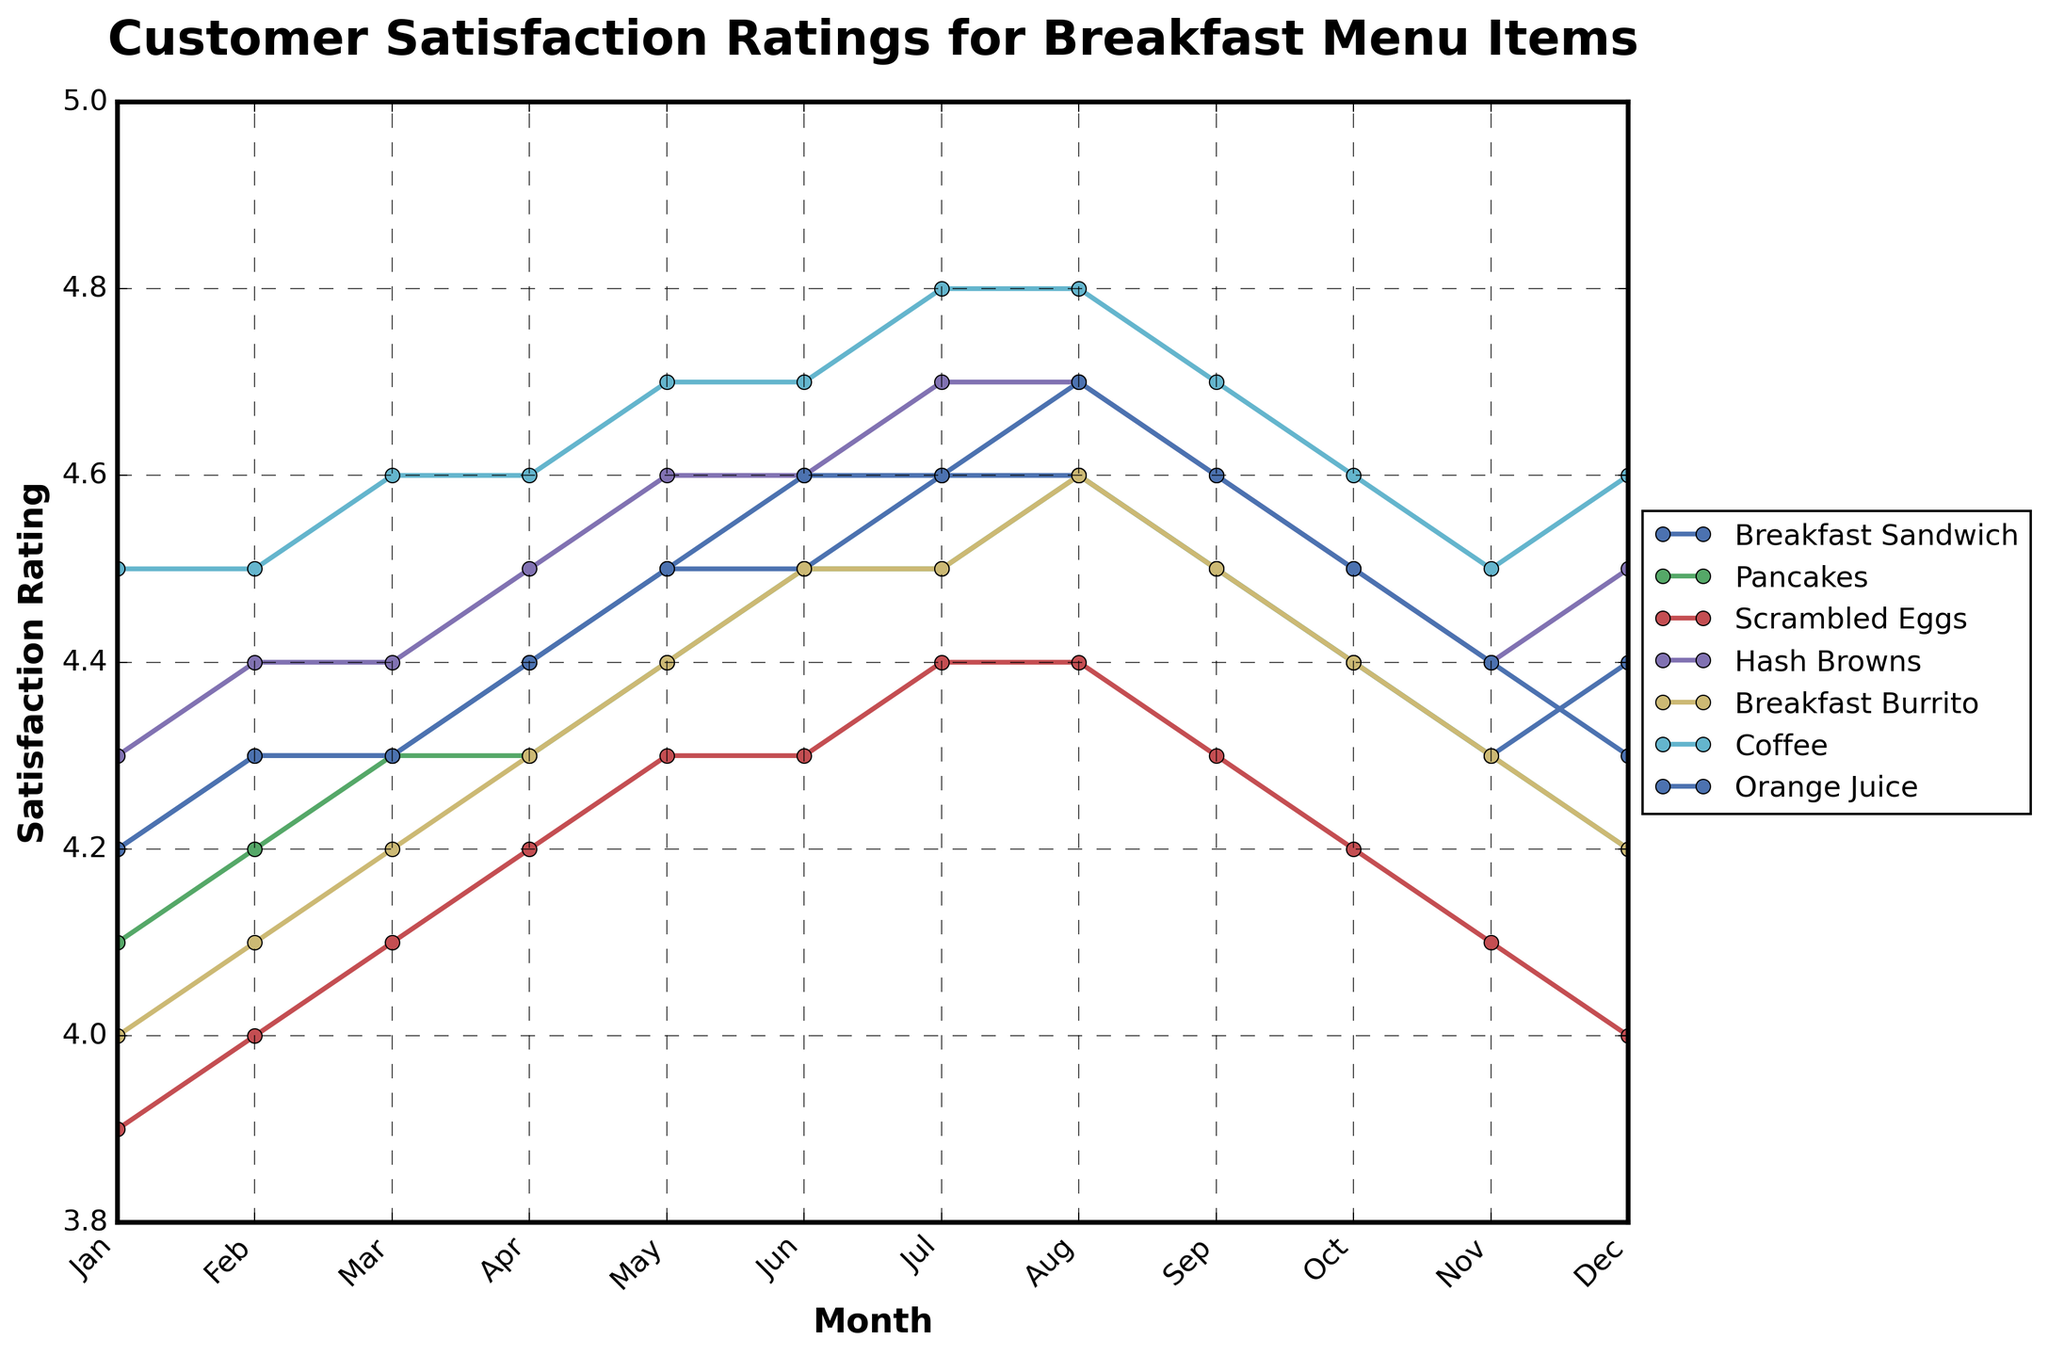What's the trend in customer satisfaction ratings for the Coffee over the year? The Coffee's customer satisfaction ratings generally increase from January (4.5) to August (4.8) and then slightly decline towards December (4.6).
Answer: Increasing trend with a slight decline towards the end Which item had the highest satisfaction rating in December? In December, Coffee had the highest satisfaction rating with a value of 4.6.
Answer: Coffee Compare the satisfaction ratings of Breakfast Sandwich and Pancakes in May. Which one had a higher rating? In May, the Breakfast Sandwich had a satisfaction rating of 4.5, while the Pancakes had a rating of 4.4. Thus, the Breakfast Sandwich had a higher rating.
Answer: Breakfast Sandwich Which item showed the most consistent increase in satisfaction ratings throughout the year? Scrambled Eggs showed a consistent increase from January (3.9) to December (4.0) with no months showing a decrease. Thus, it had the most consistent increase.
Answer: Scrambled Eggs What is the difference between the highest and lowest satisfaction ratings for the Hash Browns over the year? The highest satisfaction rating for Hash Browns is 4.7 (July, August), and the lowest is 4.3 (January). The difference is 4.7 - 4.3 = 0.4.
Answer: 0.4 What's the average satisfaction rating for Orange Juice from January to June? The satisfaction ratings for Orange Juice from January to June are 4.2, 4.3, 4.3, 4.4, 4.5, and 4.6. Summing them gives 26.3. The average is 26.3 / 6 ≈ 4.38.
Answer: 4.38 Which month shows the highest satisfaction rating across all items? In July, Coffee had a rating of 4.8, which is the highest satisfaction rating across all items and months.
Answer: July How do the satisfaction ratings for the Breakfast Burrito compare between January and June? In January, the Breakfast Burrito's satisfaction rating is 4.0, and in June, it is 4.5. Therefore, the rating increased by 0.5 points from January to June.
Answer: Increased by 0.5 Identify the item with a satisfaction rating of 4.1 in March. Checking the data, Scrambled Eggs and Breakfast Burrito had a satisfaction rating of 4.1 in March.
Answer: Scrambled Eggs, Breakfast Burrito 